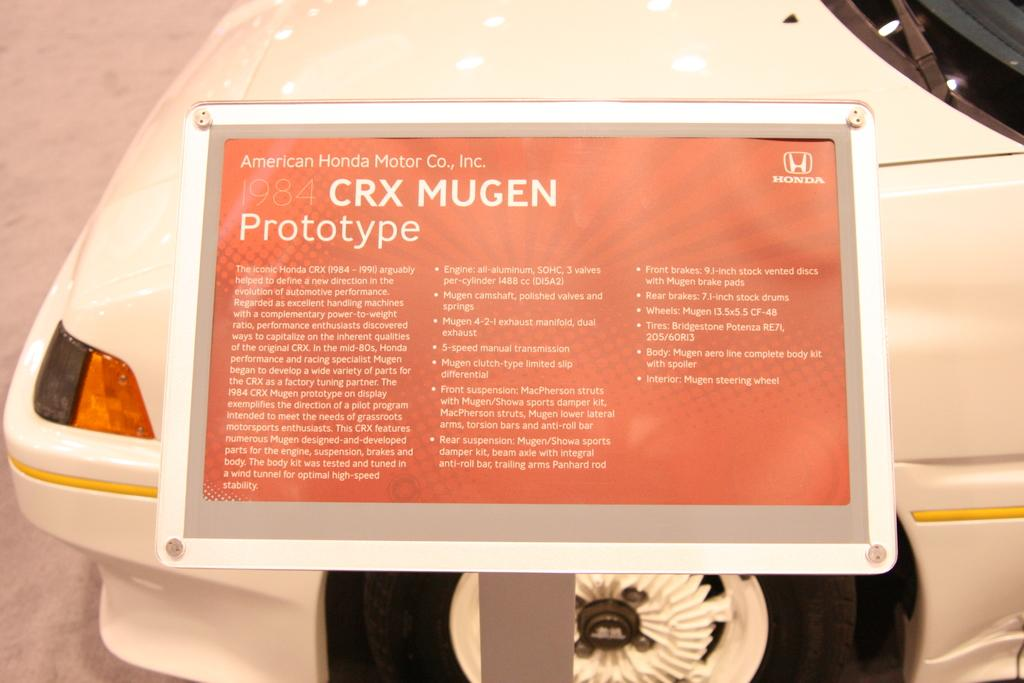What is on the board that is visible in the image? There is text on the board in the image. What else can be seen on the floor in the image? There is a vehicle on the floor in the image. What type of impulse can be seen affecting the vehicle in the image? There is no impulse affecting the vehicle in the image; it is stationary on the floor. What kind of pot is present on the board with text in the image? There is no pot present on the board with text in the image. 